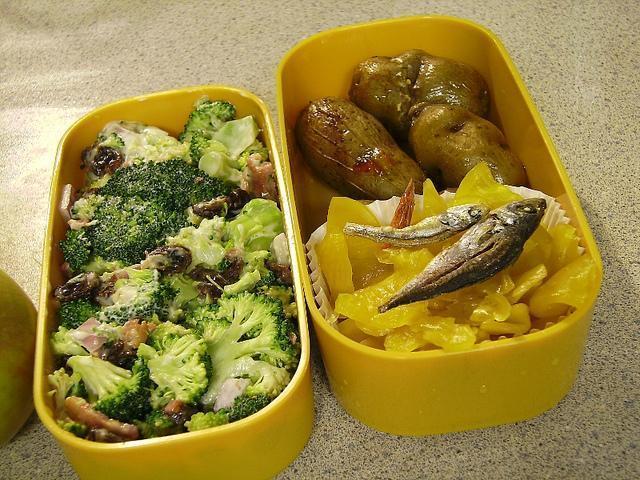How many bowls are in the picture?
Give a very brief answer. 2. How many broccolis can be seen?
Give a very brief answer. 8. 